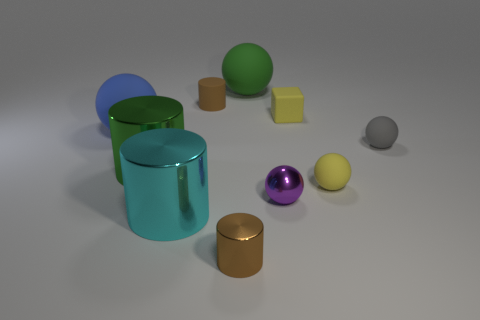Subtract all yellow blocks. How many brown cylinders are left? 2 Subtract all large cyan cylinders. How many cylinders are left? 3 Subtract all green balls. How many balls are left? 4 Subtract all blocks. How many objects are left? 9 Subtract all purple cylinders. Subtract all green cubes. How many cylinders are left? 4 Add 6 small blue shiny objects. How many small blue shiny objects exist? 6 Subtract 1 yellow spheres. How many objects are left? 9 Subtract all small yellow matte balls. Subtract all tiny yellow balls. How many objects are left? 8 Add 8 green matte things. How many green matte things are left? 9 